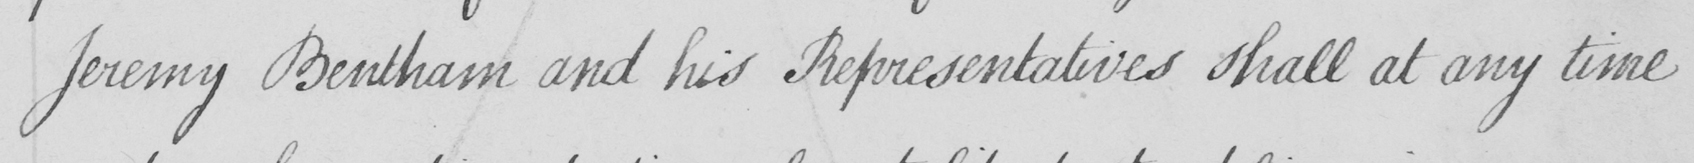What text is written in this handwritten line? Jeremy Bentham and his Representatives shall at any time 